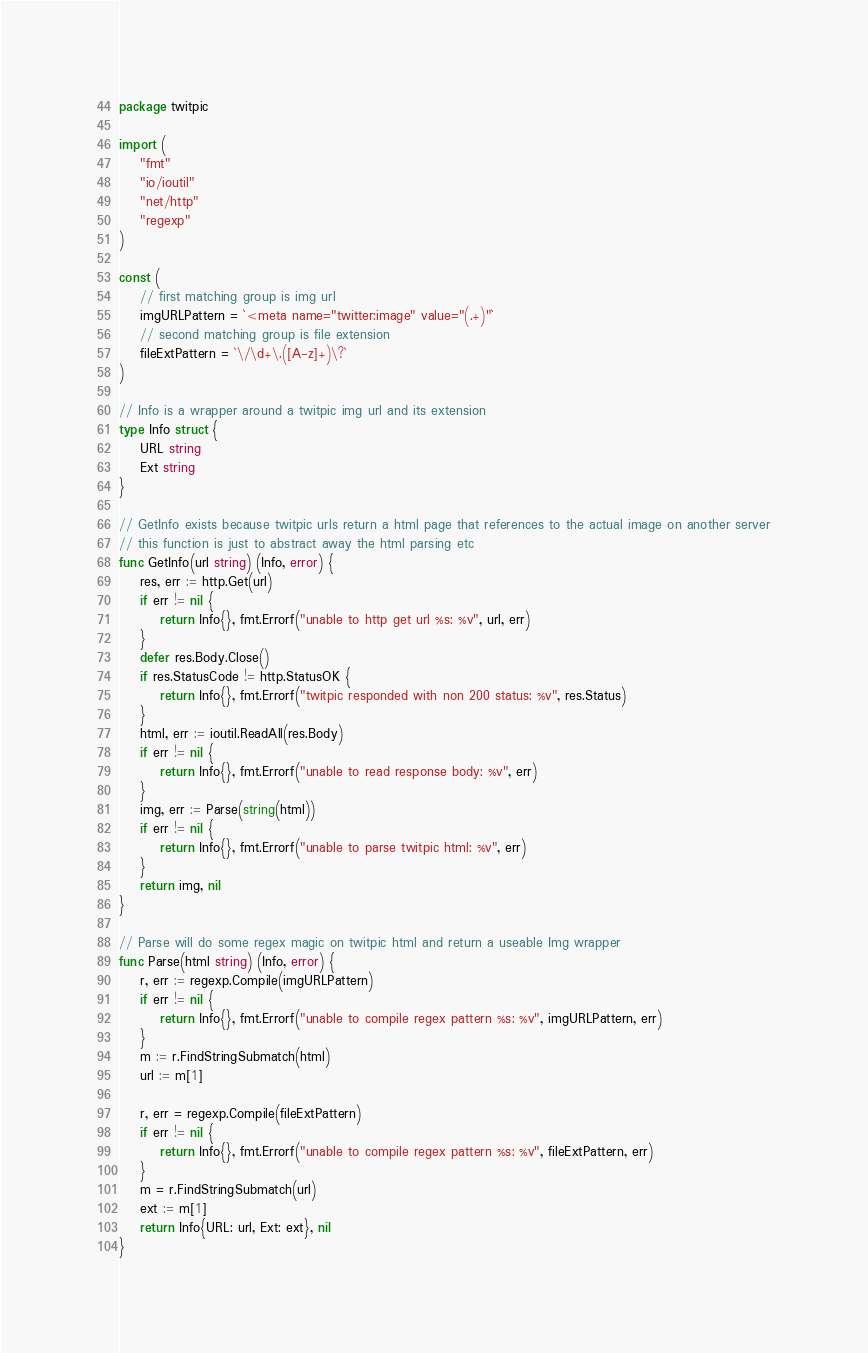Convert code to text. <code><loc_0><loc_0><loc_500><loc_500><_Go_>package twitpic

import (
	"fmt"
	"io/ioutil"
	"net/http"
	"regexp"
)

const (
	// first matching group is img url
	imgURLPattern = `<meta name="twitter:image" value="(.+)"`
	// second matching group is file extension
	fileExtPattern = `\/\d+\.([A-z]+)\?`
)

// Info is a wrapper around a twitpic img url and its extension
type Info struct {
	URL string
	Ext string
}

// GetInfo exists because twitpic urls return a html page that references to the actual image on another server
// this function is just to abstract away the html parsing etc
func GetInfo(url string) (Info, error) {
	res, err := http.Get(url)
	if err != nil {
		return Info{}, fmt.Errorf("unable to http get url %s: %v", url, err)
	}
	defer res.Body.Close()
	if res.StatusCode != http.StatusOK {
		return Info{}, fmt.Errorf("twitpic responded with non 200 status: %v", res.Status)
	}
	html, err := ioutil.ReadAll(res.Body)
	if err != nil {
		return Info{}, fmt.Errorf("unable to read response body: %v", err)
	}
	img, err := Parse(string(html))
	if err != nil {
		return Info{}, fmt.Errorf("unable to parse twitpic html: %v", err)
	}
	return img, nil
}

// Parse will do some regex magic on twitpic html and return a useable Img wrapper
func Parse(html string) (Info, error) {
	r, err := regexp.Compile(imgURLPattern)
	if err != nil {
		return Info{}, fmt.Errorf("unable to compile regex pattern %s: %v", imgURLPattern, err)
	}
	m := r.FindStringSubmatch(html)
	url := m[1]

	r, err = regexp.Compile(fileExtPattern)
	if err != nil {
		return Info{}, fmt.Errorf("unable to compile regex pattern %s: %v", fileExtPattern, err)
	}
	m = r.FindStringSubmatch(url)
	ext := m[1]
	return Info{URL: url, Ext: ext}, nil
}
</code> 